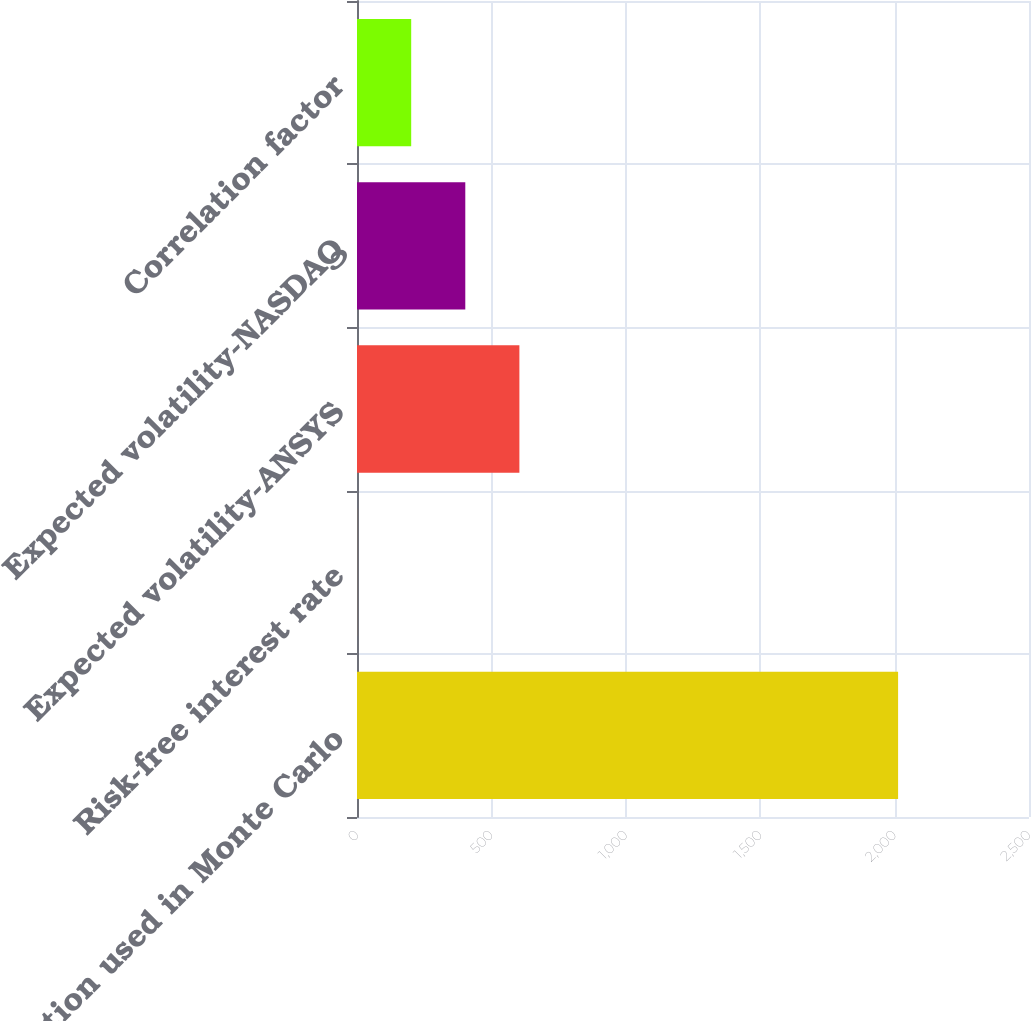<chart> <loc_0><loc_0><loc_500><loc_500><bar_chart><fcel>Assumption used in Monte Carlo<fcel>Risk-free interest rate<fcel>Expected volatility-ANSYS<fcel>Expected volatility-NASDAQ<fcel>Correlation factor<nl><fcel>2013<fcel>0.35<fcel>604.14<fcel>402.88<fcel>201.62<nl></chart> 